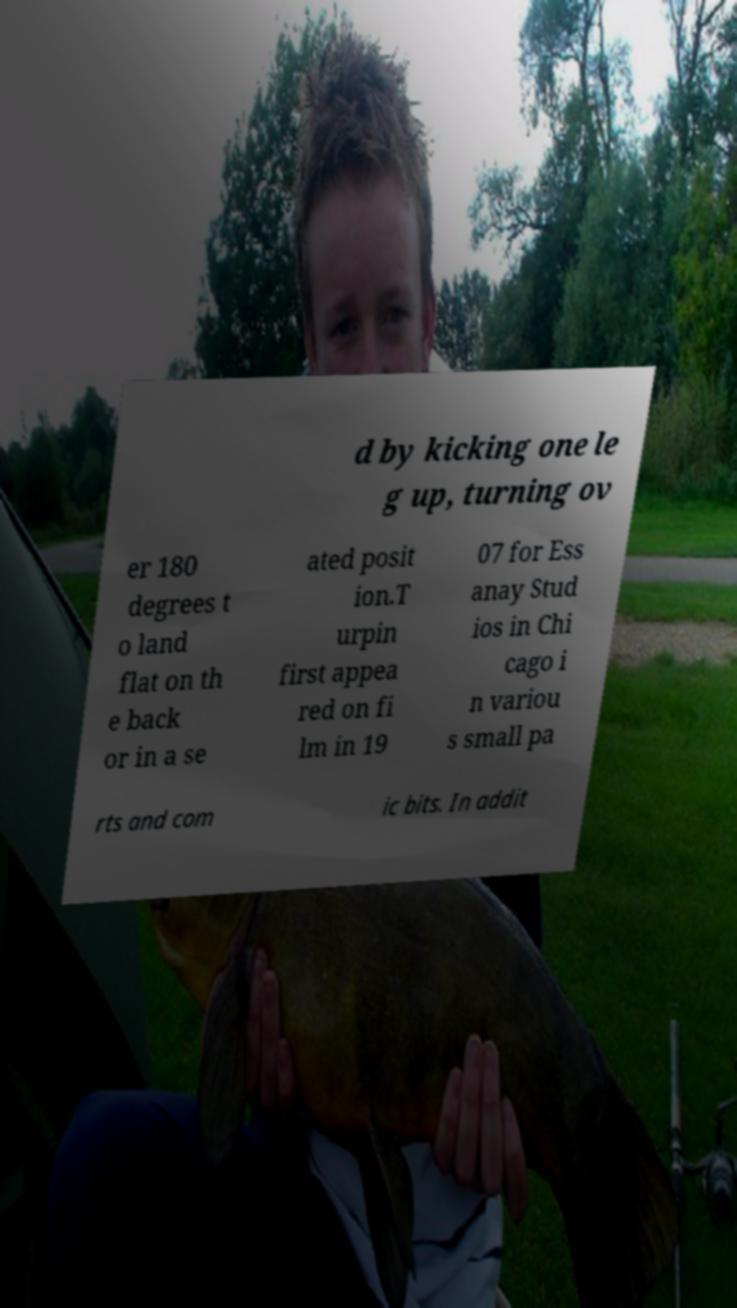Can you accurately transcribe the text from the provided image for me? d by kicking one le g up, turning ov er 180 degrees t o land flat on th e back or in a se ated posit ion.T urpin first appea red on fi lm in 19 07 for Ess anay Stud ios in Chi cago i n variou s small pa rts and com ic bits. In addit 